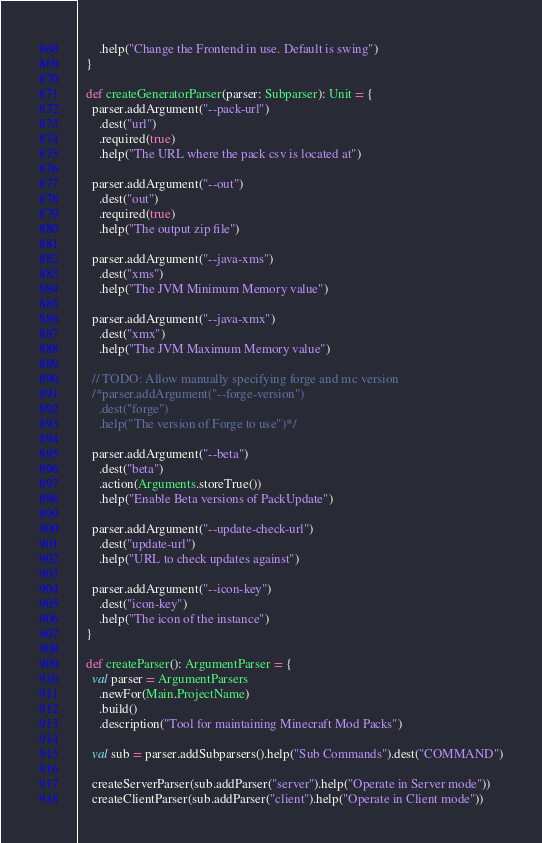Convert code to text. <code><loc_0><loc_0><loc_500><loc_500><_Scala_>      .help("Change the Frontend in use. Default is swing")
  }

  def createGeneratorParser(parser: Subparser): Unit = {
    parser.addArgument("--pack-url")
      .dest("url")
      .required(true)
      .help("The URL where the pack csv is located at")

    parser.addArgument("--out")
      .dest("out")
      .required(true)
      .help("The output zip file")

    parser.addArgument("--java-xms")
      .dest("xms")
      .help("The JVM Minimum Memory value")

    parser.addArgument("--java-xmx")
      .dest("xmx")
      .help("The JVM Maximum Memory value")

    // TODO: Allow manually specifying forge and mc version
    /*parser.addArgument("--forge-version")
      .dest("forge")
      .help("The version of Forge to use")*/

    parser.addArgument("--beta")
      .dest("beta")
      .action(Arguments.storeTrue())
      .help("Enable Beta versions of PackUpdate")

    parser.addArgument("--update-check-url")
      .dest("update-url")
      .help("URL to check updates against")

    parser.addArgument("--icon-key")
      .dest("icon-key")
      .help("The icon of the instance")
  }

  def createParser(): ArgumentParser = {
    val parser = ArgumentParsers
      .newFor(Main.ProjectName)
      .build()
      .description("Tool for maintaining Minecraft Mod Packs")

    val sub = parser.addSubparsers().help("Sub Commands").dest("COMMAND")

    createServerParser(sub.addParser("server").help("Operate in Server mode"))
    createClientParser(sub.addParser("client").help("Operate in Client mode"))</code> 